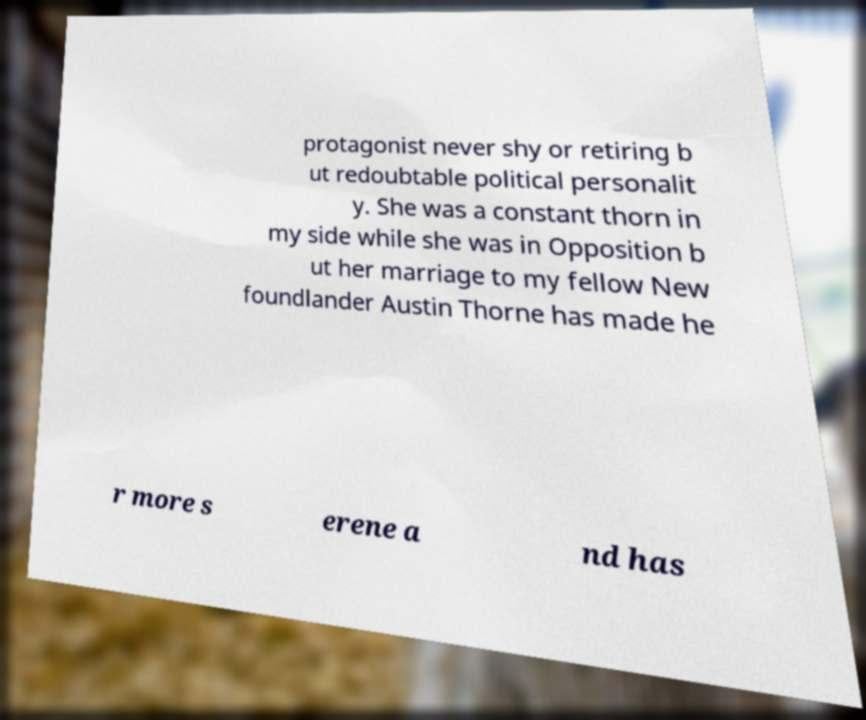Please read and relay the text visible in this image. What does it say? protagonist never shy or retiring b ut redoubtable political personalit y. She was a constant thorn in my side while she was in Opposition b ut her marriage to my fellow New foundlander Austin Thorne has made he r more s erene a nd has 